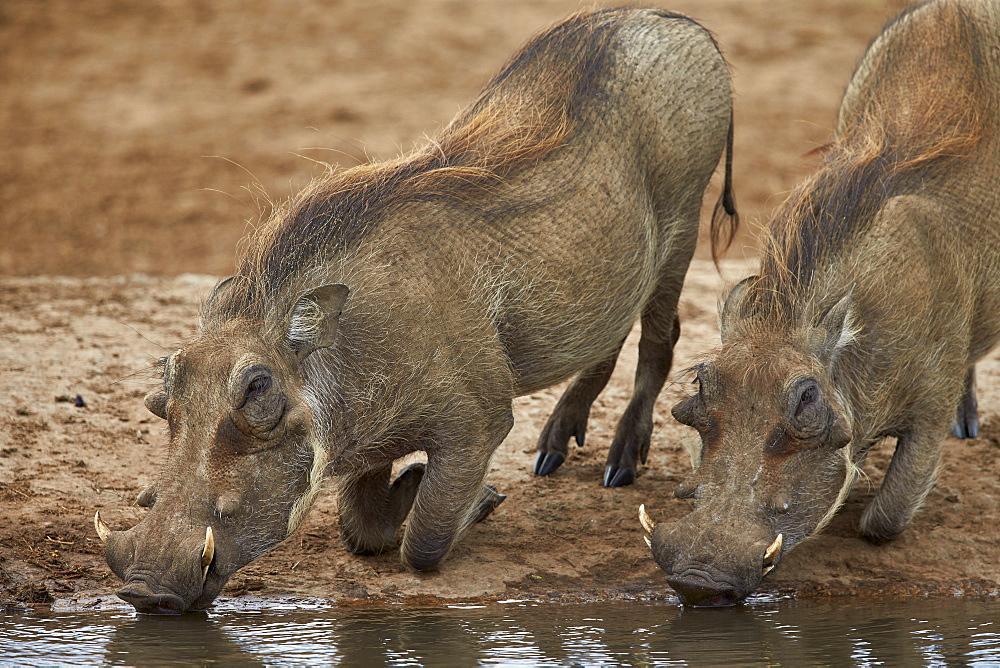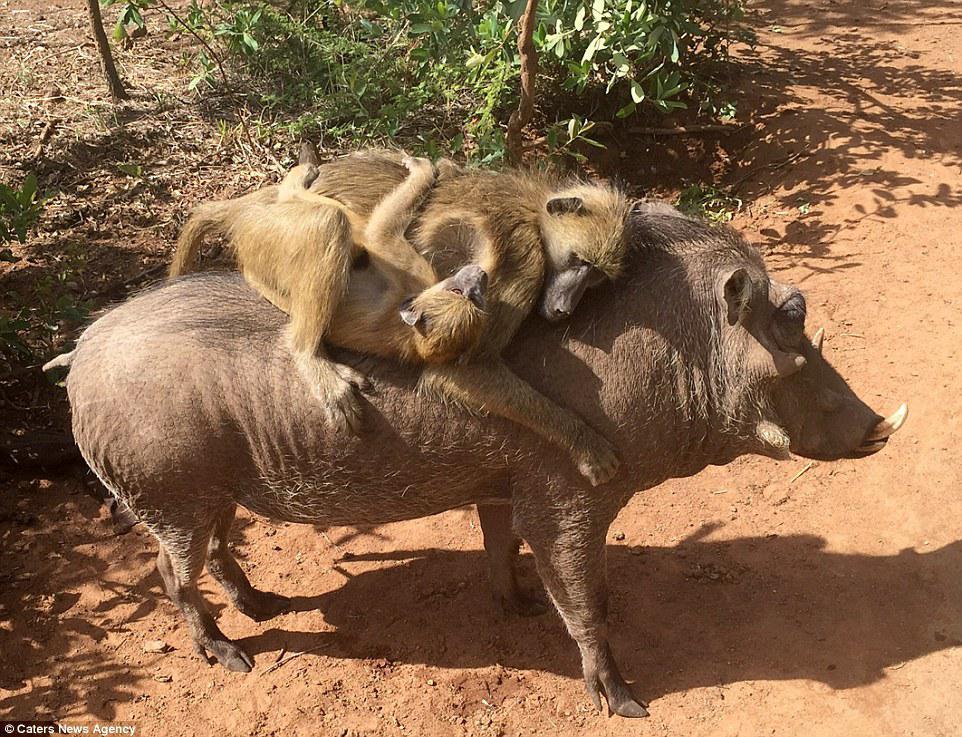The first image is the image on the left, the second image is the image on the right. Analyze the images presented: Is the assertion "There are two wart hogs in the right image that are both facing towards the left." valid? Answer yes or no. No. The first image is the image on the left, the second image is the image on the right. Analyze the images presented: Is the assertion "In one image two warthog is drinking out of a lake." valid? Answer yes or no. Yes. 